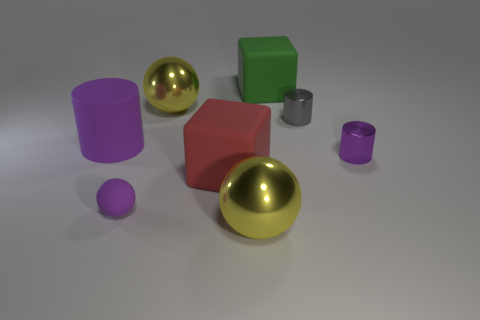Subtract all cyan blocks. Subtract all yellow cylinders. How many blocks are left? 2 Add 1 cylinders. How many objects exist? 9 Subtract all cubes. How many objects are left? 6 Add 8 small gray blocks. How many small gray blocks exist? 8 Subtract 0 gray cubes. How many objects are left? 8 Subtract all big gray matte cylinders. Subtract all purple things. How many objects are left? 5 Add 6 big cubes. How many big cubes are left? 8 